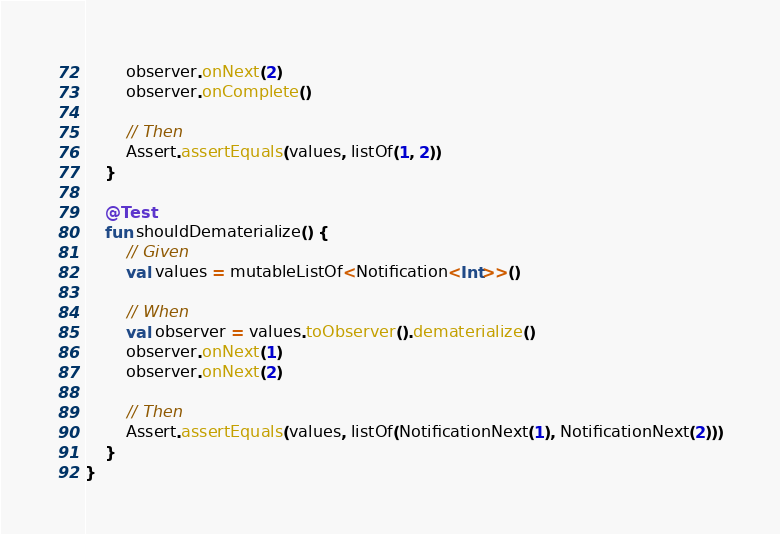Convert code to text. <code><loc_0><loc_0><loc_500><loc_500><_Kotlin_>        observer.onNext(2)
        observer.onComplete()

        // Then
        Assert.assertEquals(values, listOf(1, 2))
    }

    @Test
    fun shouldDematerialize() {
        // Given
        val values = mutableListOf<Notification<Int>>()

        // When
        val observer = values.toObserver().dematerialize()
        observer.onNext(1)
        observer.onNext(2)

        // Then
        Assert.assertEquals(values, listOf(NotificationNext(1), NotificationNext(2)))
    }
}</code> 